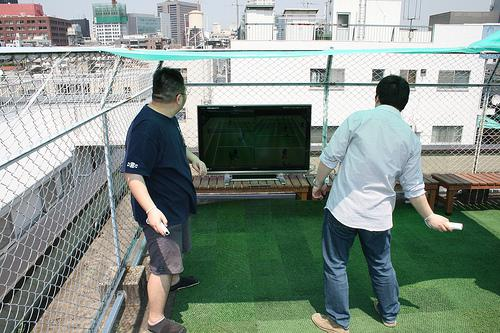Question: who is standing on the right of picture?
Choices:
A. Person.
B. The man in white shirt.
C. People.
D. Man.
Answer with the letter. Answer: B Question: what do the men have in their hands?
Choices:
A. Remote.
B. Toy.
C. Game controller.
D. Signal.
Answer with the letter. Answer: C Question: why do the men have game controllers in their hand?
Choices:
A. Having fun.
B. Competing.
C. Challenge.
D. Playing game.
Answer with the letter. Answer: D Question: what are the people in picture doing?
Choices:
A. Playing game.
B. Having fun.
C. Competing.
D. Playing.
Answer with the letter. Answer: A 